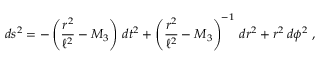Convert formula to latex. <formula><loc_0><loc_0><loc_500><loc_500>d s ^ { 2 } = - \left ( { \frac { r ^ { 2 } } { \ell ^ { 2 } } } - M _ { 3 } \right ) \, d t ^ { 2 } + \left ( { \frac { r ^ { 2 } } { \ell ^ { 2 } } } - M _ { 3 } \right ) ^ { - 1 } \, d r ^ { 2 } + r ^ { 2 } \, d \phi ^ { 2 } \ ,</formula> 